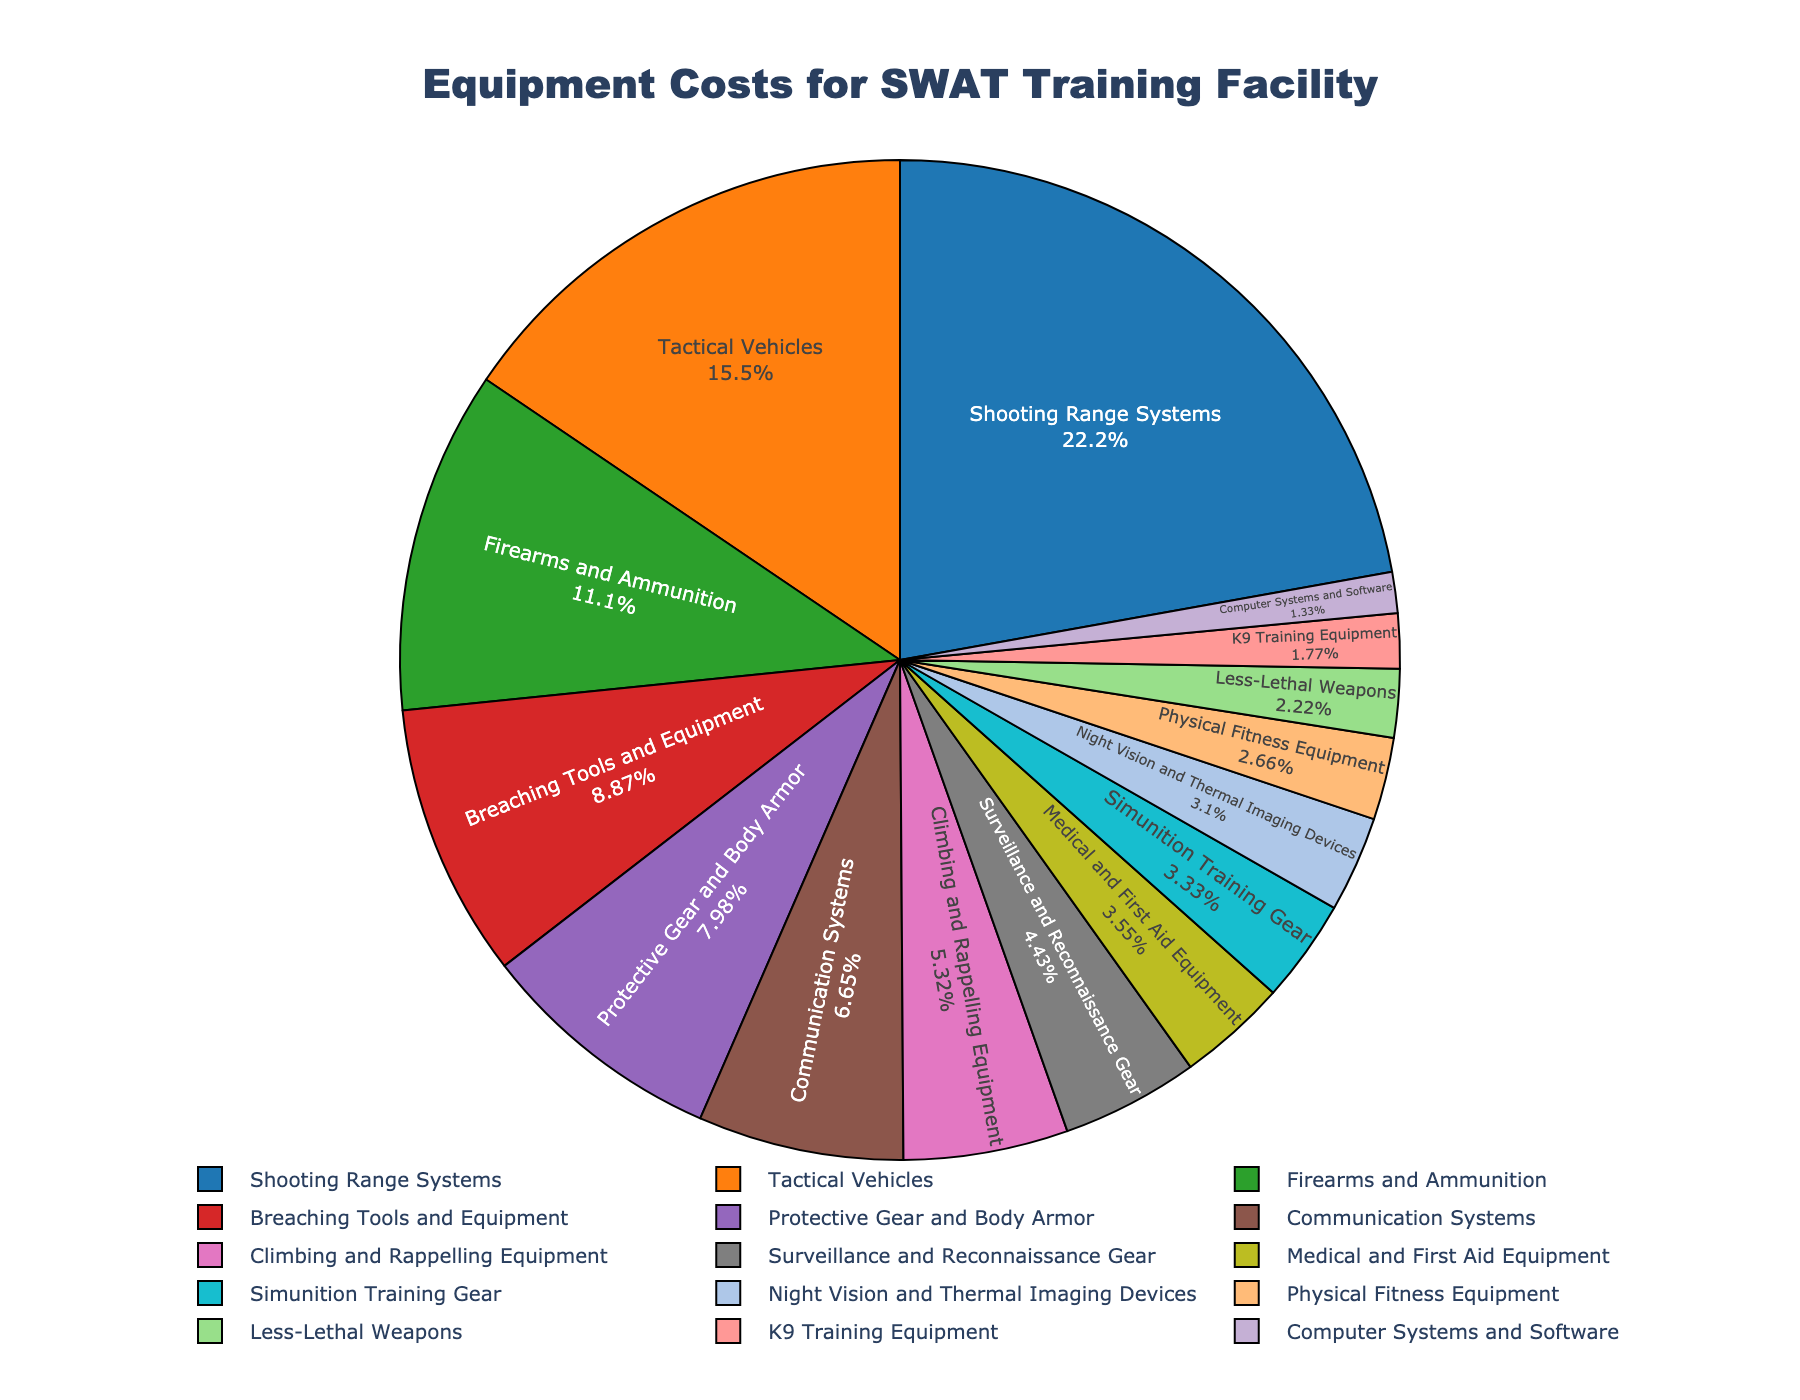What's the percentage cost of Tactical Vehicles? Locate Tactical Vehicles in the pie chart and read the percentage indicated inside or next to the segment.
Answer: 17.5% Which equipment type has the smallest cost, and what percentage does it represent? Identify the smallest segment in the pie chart, which corresponds to Computer Systems and Software, and read the percentage indicated.
Answer: Computer Systems and Software, 1.5% What's the total cost for equipment items categorized as shooting, firearms, and ammunition? Sum the costs of Shooting Range Systems ($500,000) and Firearms and Ammunition ($250,000).
Answer: $750,000 How much more is spent on Tactical Vehicles compared to Communication Systems? Find the cost of Tactical Vehicles ($350,000) and Communication Systems ($150,000), then subtract the latter from the former.
Answer: $200,000 What are the three costliest equipment types, and what is their total percentage contribution? Identify the three largest segments: Shooting Range Systems (25%), Tactical Vehicles (17.5%), Firearms and Ammunition (12.5%), then sum these percentages.
Answer: Shooting Range Systems, Tactical Vehicles, Firearms and Ammunition; 55% Which equipment types have a cost less than $100,000, and what are their respective percentages? Identify segments with costs under $100,000: Surveillance and Reconnaissance Gear (5%), Medical and First Aid Equipment (4%), Simunition Training Gear (3.75%), Night Vision and Thermal Imaging Devices (3.5%), Physical Fitness Equipment (3%), Less-Lethal Weapons (2.5%), K9 Training Equipment (2%), Computer Systems and Software (1.5%).
Answer: Surveillance and Reconnaissance Gear, 5%; Medical and First Aid Equipment, 4%; Simunition Training Gear, 3.75%; Night Vision and Thermal Imaging Devices, 3.5%; Physical Fitness Equipment, 3%; Less-Lethal Weapons, 2.5%; K9 Training Equipment, 2%; Computer Systems and Software, 1.5% By how much does the cost of Breaching Tools and Equipment exceed that of Protective Gear and Body Armor? Find the costs of Breaching Tools and Equipment ($200,000) and Protective Gear and Body Armor ($180,000), then subtract the latter from the former.
Answer: $20,000 What is the combined percentage of Climbing and Rappelling Equipment and Surveillance and Reconnaissance Gear? Find both percentages on the pie chart (Climbing and Rappelling Equipment: 6%, Surveillance and Reconnaissance Gear: 5%), then sum them.
Answer: 11% Is the cost of Medical and First Aid Equipment more than less-lethal weapons? If so, by how much percent? Compare segments for Medical and First Aid Equipment (4%) and Less-Lethal Weapons (2.5%), then find the difference.
Answer: Yes, by 1.5% 